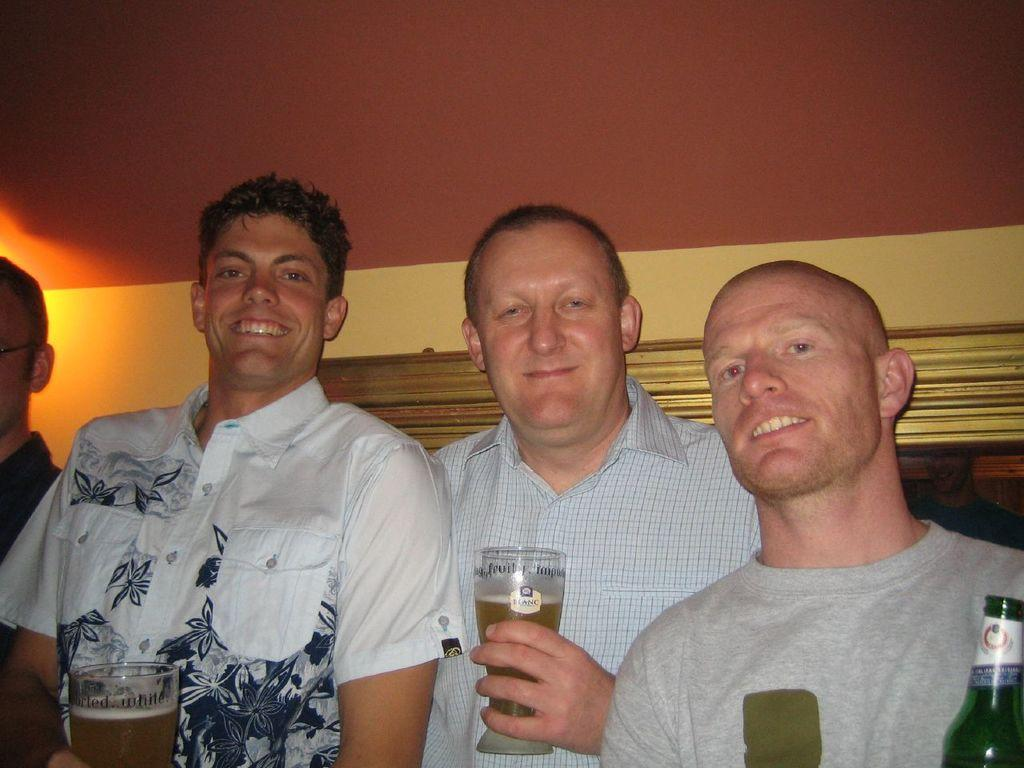Where is the setting of the image? The image is inside a room. How many men are present in the image? There are four men standing in the image. What object can be seen in the image related to drinking? There is a wine glass in the image. What color is the wall in the background of the image? The wall in the background of the image is yellow. What color is the roof in the image? The roof is in red color. What type of creature is sitting on the cent in the image? There is no cent or creature present in the image. 